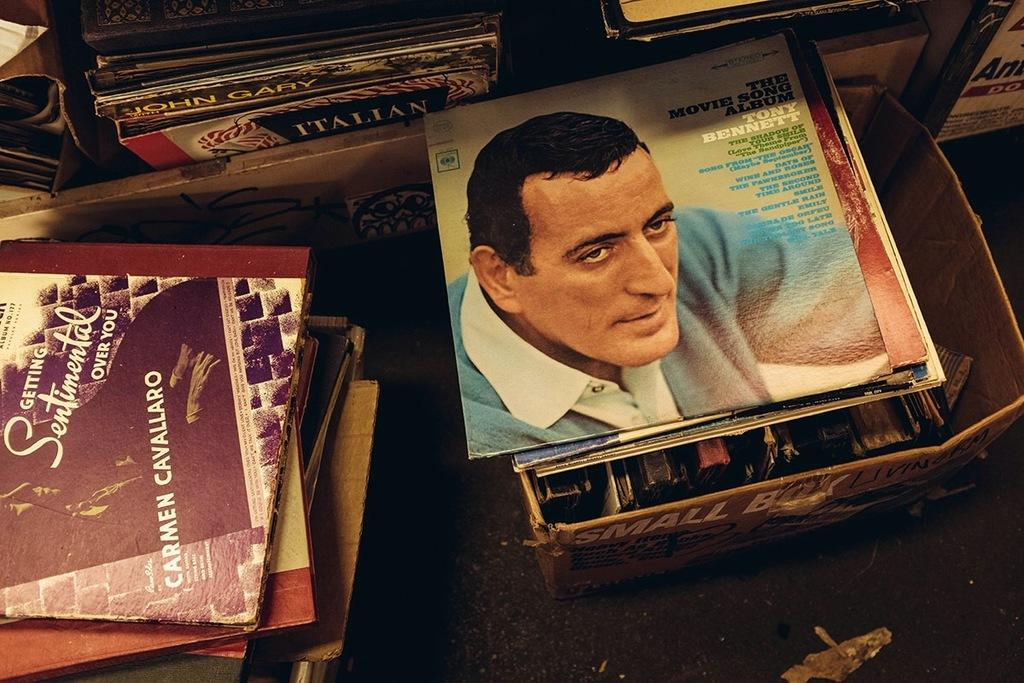<image>
Summarize the visual content of the image. Stacks of records surround The Movie Song Album by Tony Bennett. 